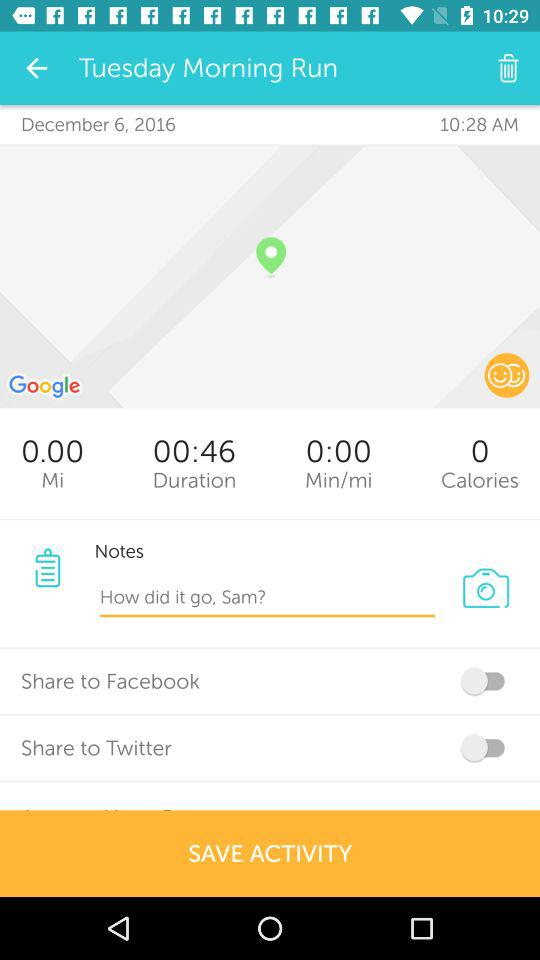How long was the activity?
Answer the question using a single word or phrase. 00:46 